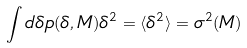Convert formula to latex. <formula><loc_0><loc_0><loc_500><loc_500>\int d \delta p ( \delta , M ) \delta ^ { 2 } = \langle \delta ^ { 2 } \rangle = \sigma ^ { 2 } ( M )</formula> 